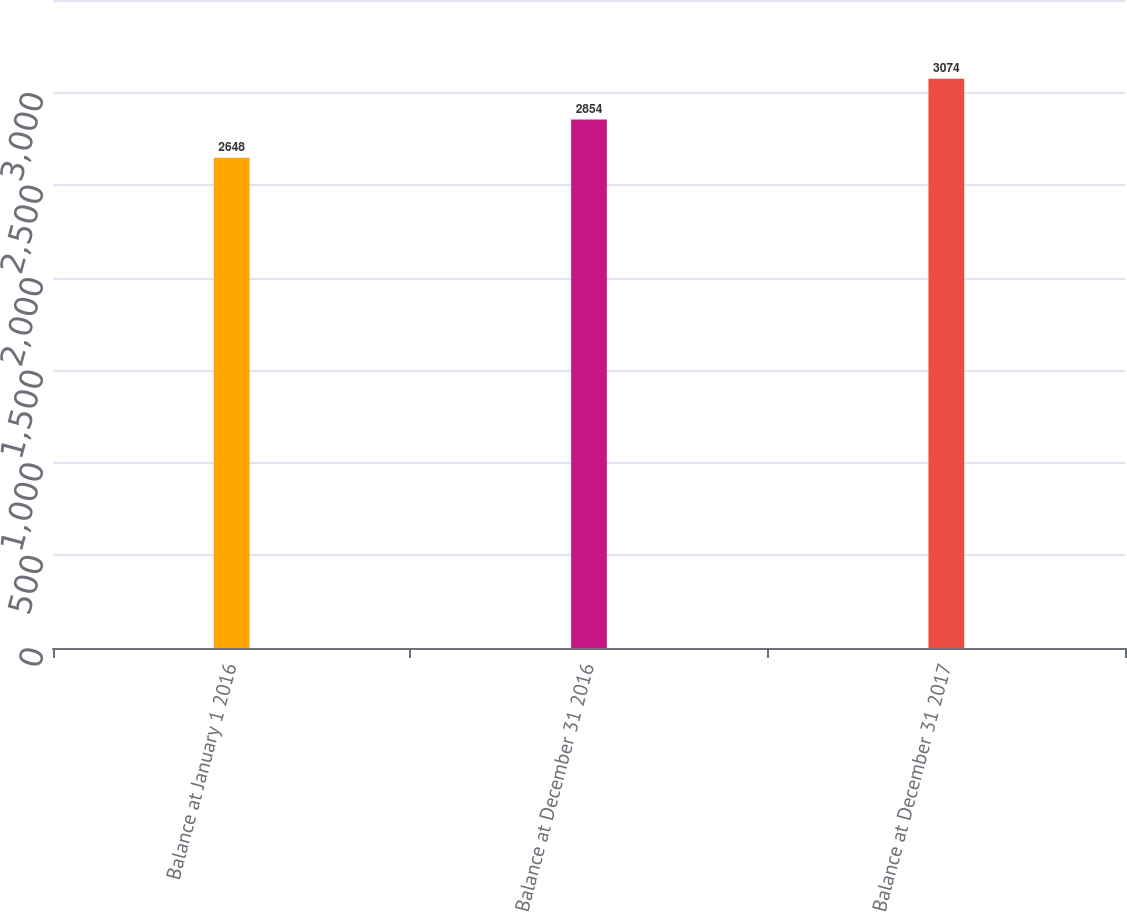Convert chart to OTSL. <chart><loc_0><loc_0><loc_500><loc_500><bar_chart><fcel>Balance at January 1 2016<fcel>Balance at December 31 2016<fcel>Balance at December 31 2017<nl><fcel>2648<fcel>2854<fcel>3074<nl></chart> 